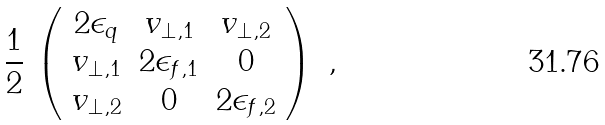<formula> <loc_0><loc_0><loc_500><loc_500>\frac { 1 } { 2 } \, \left ( \begin{array} { c c c } 2 \epsilon _ { q } & v _ { \perp , 1 } & v _ { \perp , 2 } \\ v _ { \perp , 1 } & 2 \epsilon _ { f , 1 } & 0 \\ v _ { \perp , 2 } & 0 & 2 \epsilon _ { f , 2 } \end{array} \right ) \ ,</formula> 